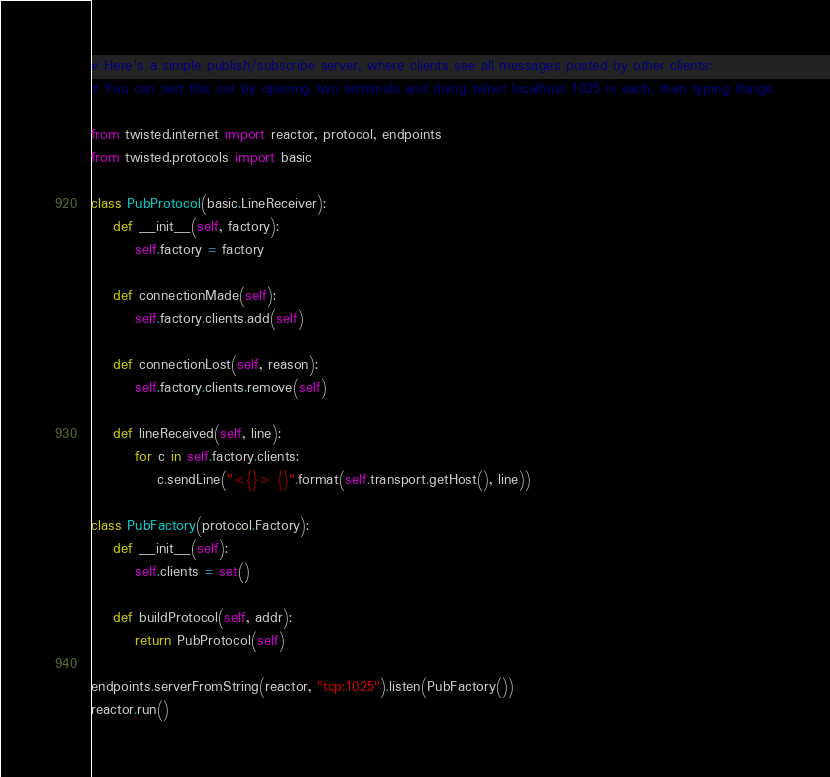<code> <loc_0><loc_0><loc_500><loc_500><_Python_>
# Here's a simple publish/subscribe server, where clients see all messages posted by other clients:
# You can test this out by opening two terminals and doing telnet localhost 1025 in each, then typing things.

from twisted.internet import reactor, protocol, endpoints
from twisted.protocols import basic

class PubProtocol(basic.LineReceiver):
    def __init__(self, factory):
        self.factory = factory

    def connectionMade(self):
        self.factory.clients.add(self)

    def connectionLost(self, reason):
        self.factory.clients.remove(self)

    def lineReceived(self, line):
        for c in self.factory.clients:
            c.sendLine("<{}> {}".format(self.transport.getHost(), line))

class PubFactory(protocol.Factory):
    def __init__(self):
        self.clients = set()

    def buildProtocol(self, addr):
        return PubProtocol(self)

endpoints.serverFromString(reactor, "tcp:1025").listen(PubFactory())
reactor.run()
</code> 